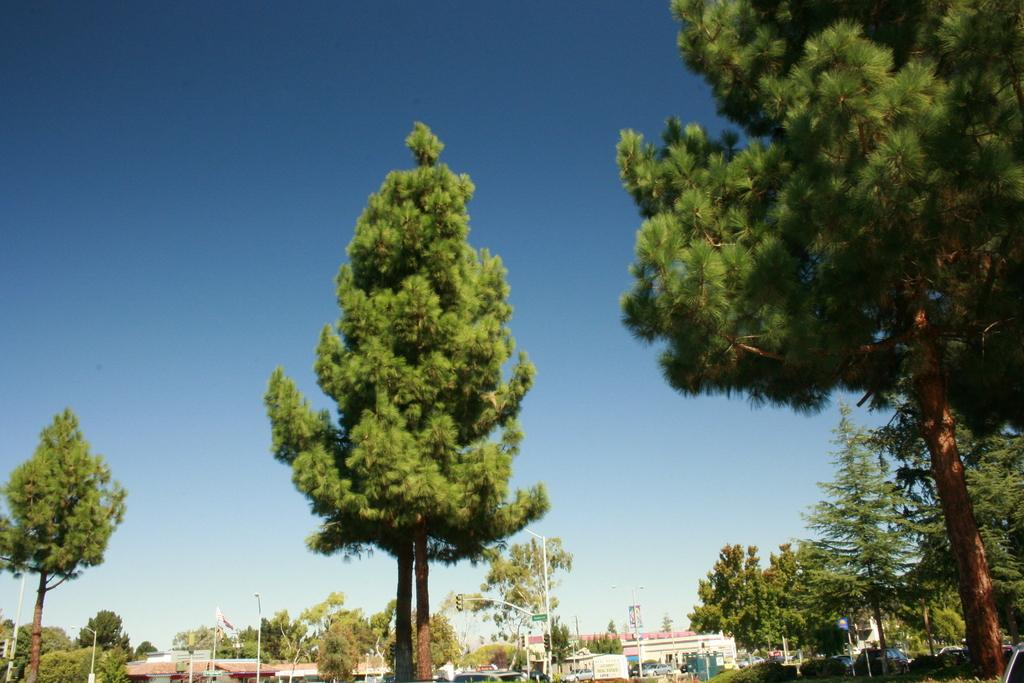What type of structures are located at the bottom of the image? There are buildings at the bottom of the image. What can be seen in the background of the image? There are trees in the background of the image. What is visible at the top of the image? The sky is visible at the top of the image. How many chickens are standing on the feet of the buildings in the image? There are no chickens or feet of buildings present in the image. What effect does the presence of the trees have on the buildings in the image? The provided facts do not mention any effect of the trees on the buildings, so we cannot answer this question. 